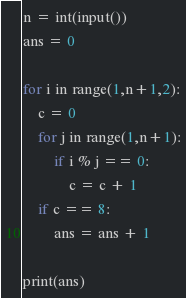Convert code to text. <code><loc_0><loc_0><loc_500><loc_500><_Python_>n = int(input())
ans = 0

for i in range(1,n+1,2):
    c = 0
    for j in range(1,n+1):
        if i % j == 0:
            c = c + 1
    if c == 8:
        ans = ans + 1

print(ans)
</code> 